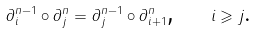<formula> <loc_0><loc_0><loc_500><loc_500>\partial ^ { n - 1 } _ { i } \circ \partial ^ { n } _ { j } = \partial ^ { n - 1 } _ { j } \circ \partial ^ { n } _ { i + 1 } \text {,} \quad i \geqslant j \text {.}</formula> 